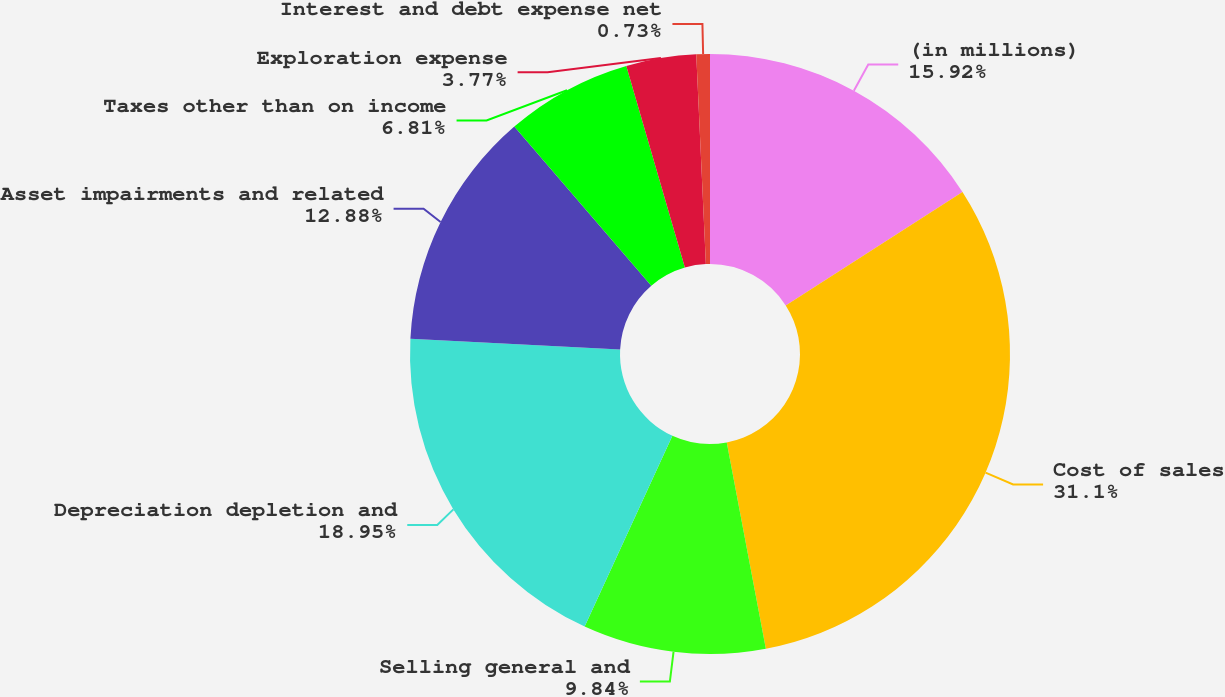Convert chart to OTSL. <chart><loc_0><loc_0><loc_500><loc_500><pie_chart><fcel>(in millions)<fcel>Cost of sales<fcel>Selling general and<fcel>Depreciation depletion and<fcel>Asset impairments and related<fcel>Taxes other than on income<fcel>Exploration expense<fcel>Interest and debt expense net<nl><fcel>15.92%<fcel>31.1%<fcel>9.84%<fcel>18.95%<fcel>12.88%<fcel>6.81%<fcel>3.77%<fcel>0.73%<nl></chart> 